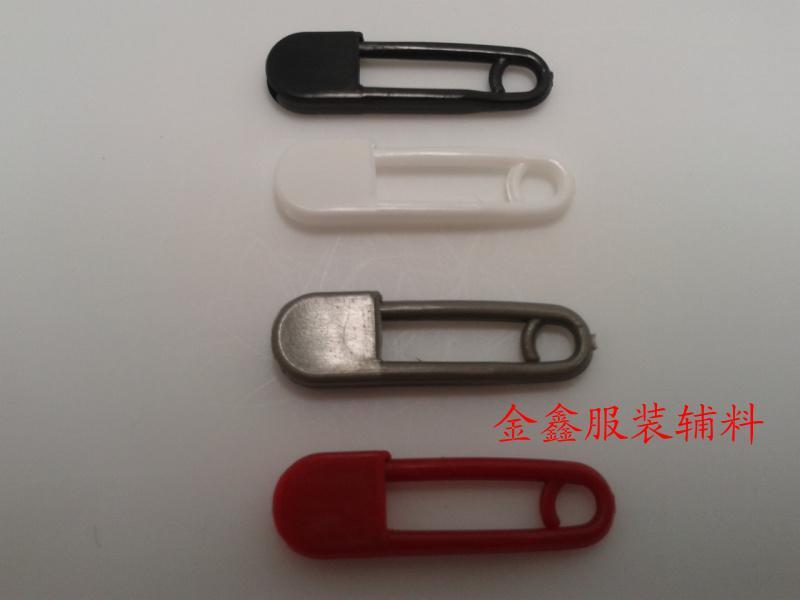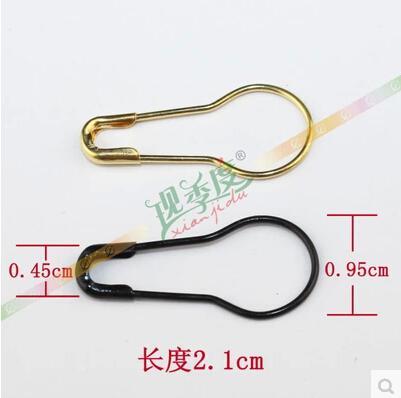The first image is the image on the left, the second image is the image on the right. Analyze the images presented: Is the assertion "There are six paperclips total." valid? Answer yes or no. Yes. 